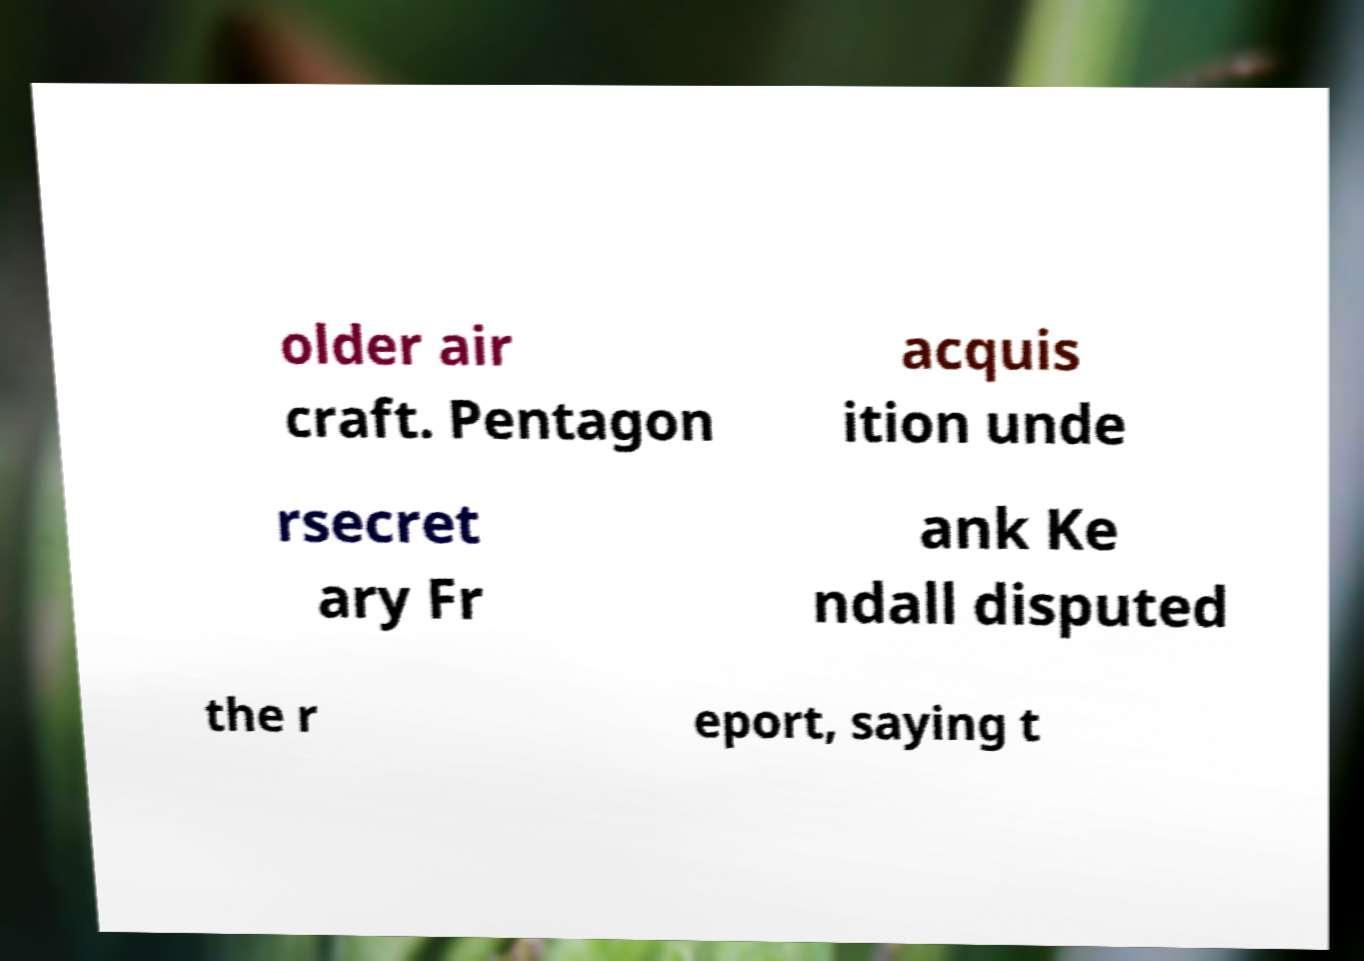Please identify and transcribe the text found in this image. older air craft. Pentagon acquis ition unde rsecret ary Fr ank Ke ndall disputed the r eport, saying t 